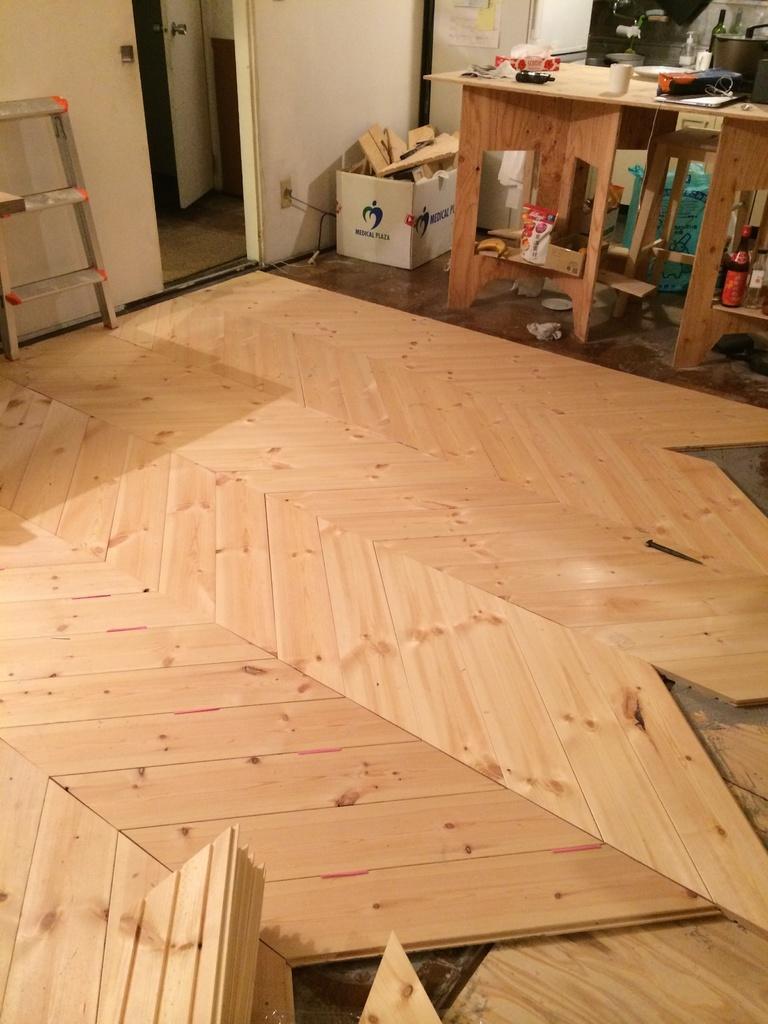In one or two sentences, can you explain what this image depicts? The picture is clicked inside a house where all the wooden furniture is on the floor To the right side of the image there are wooden tables and objects on top of it. In the background we also find a small metal ladder. 